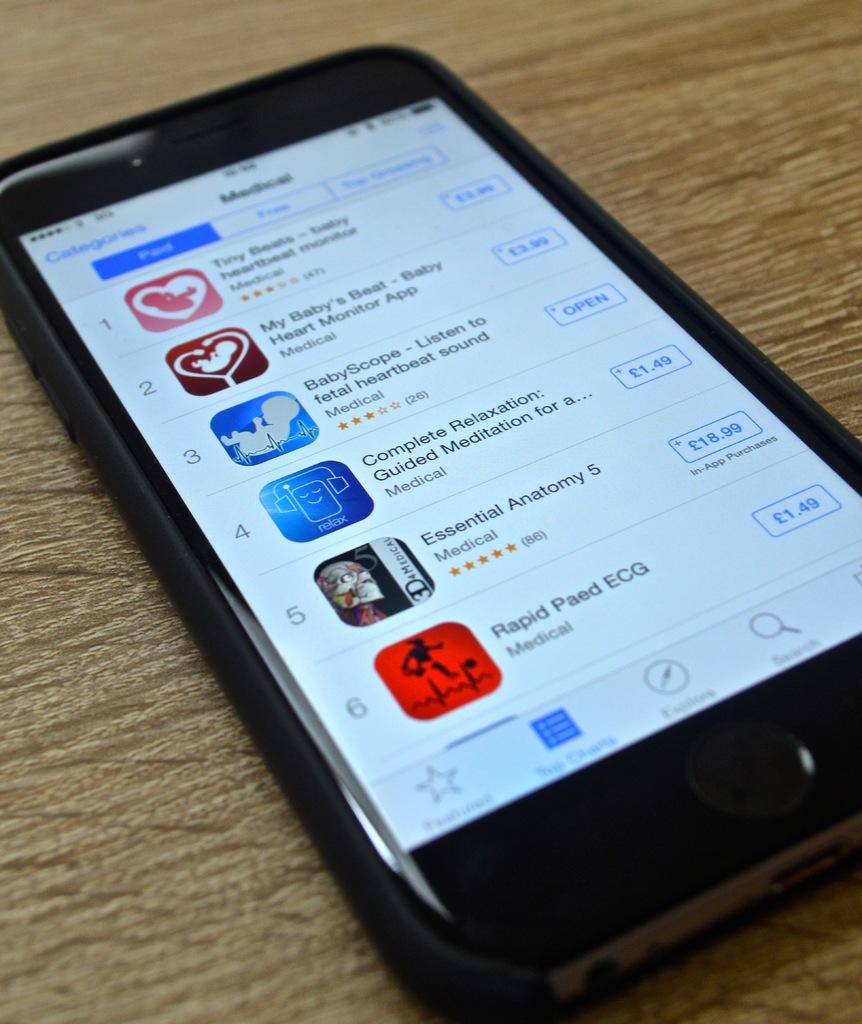Is that google play apps?
Ensure brevity in your answer.  Unanswerable. What is the app at the bottom called?
Offer a terse response. Rapid paed ecg. 